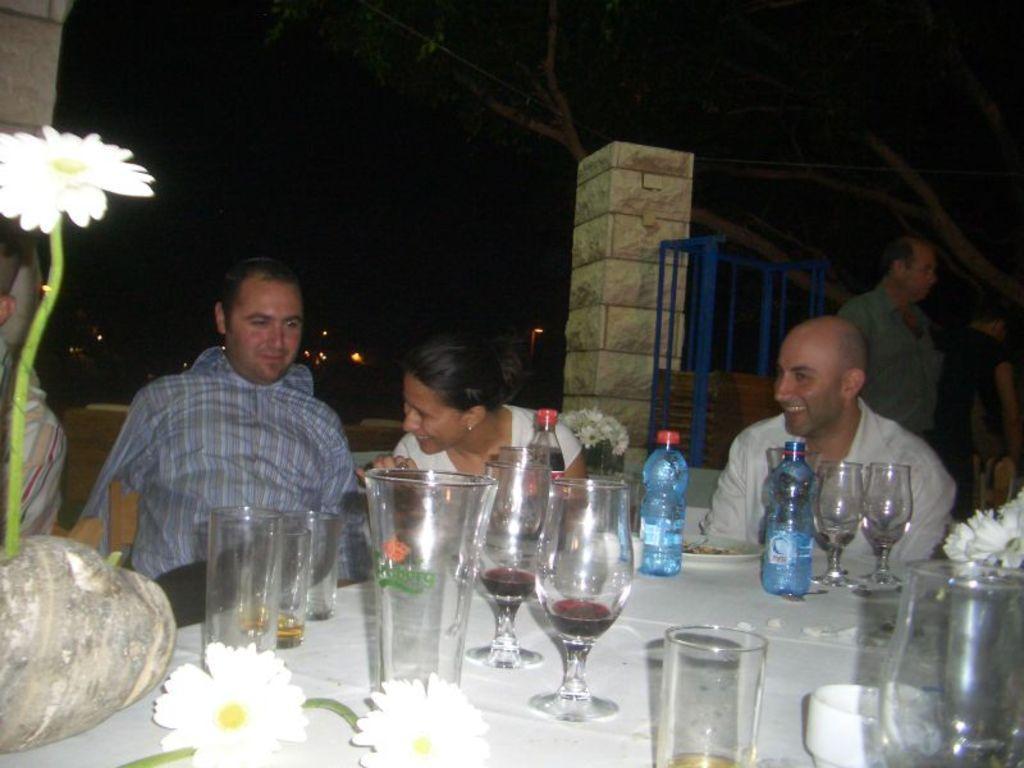Describe this image in one or two sentences. In this image there is a dining table. There are few chairs around it. People are sitting on the chairs. On the table there are glasses, bottles, flowers,cup. In the background one person is standing. There are trees, pillar in the background. 